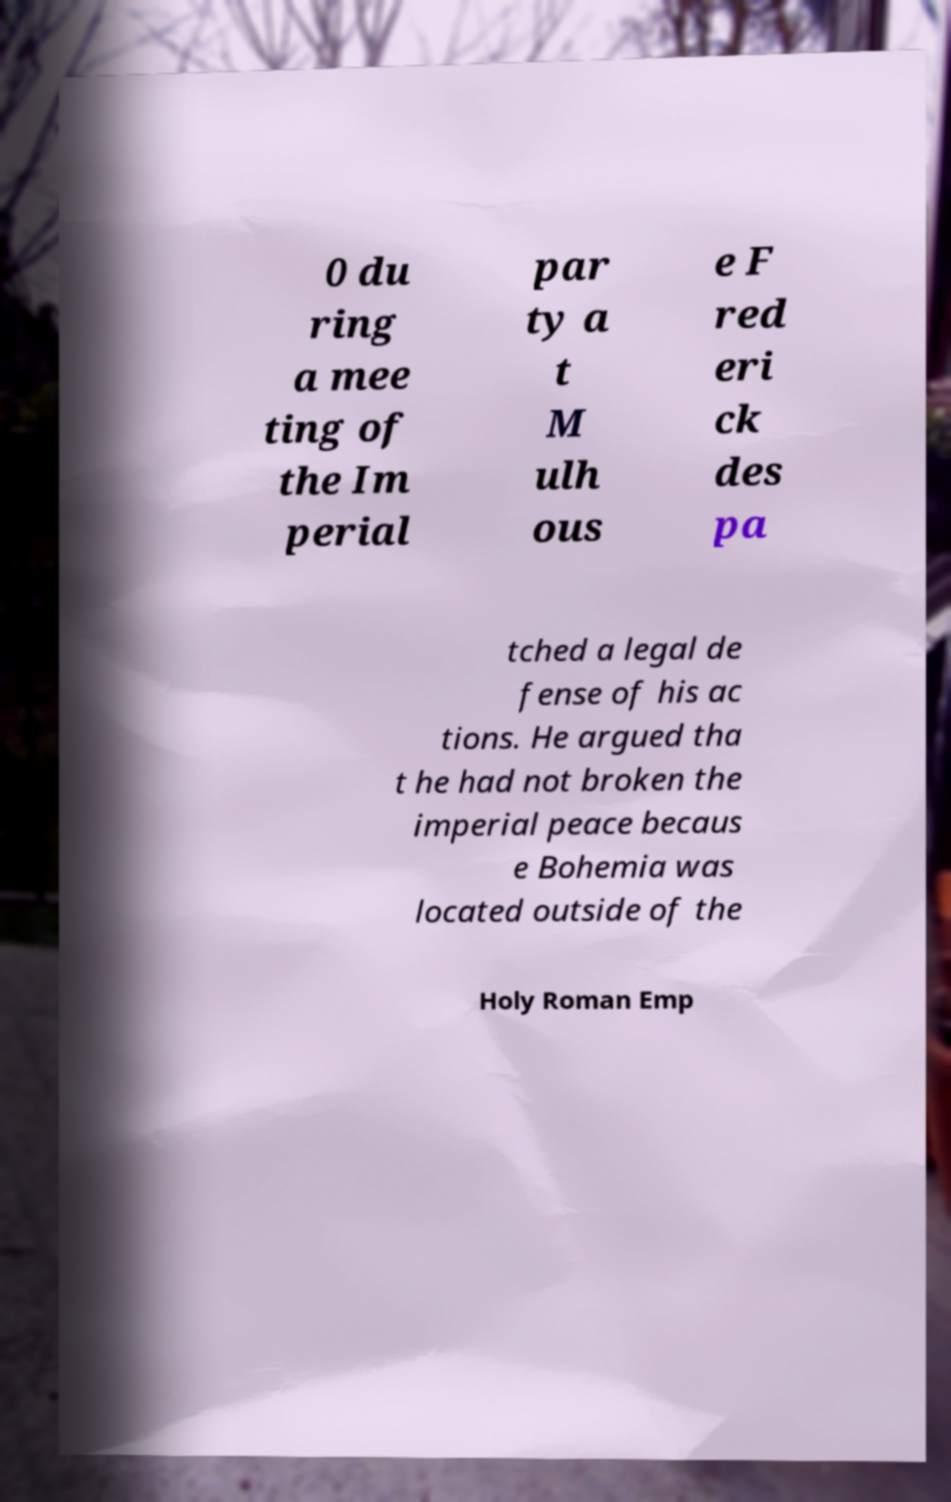There's text embedded in this image that I need extracted. Can you transcribe it verbatim? 0 du ring a mee ting of the Im perial par ty a t M ulh ous e F red eri ck des pa tched a legal de fense of his ac tions. He argued tha t he had not broken the imperial peace becaus e Bohemia was located outside of the Holy Roman Emp 